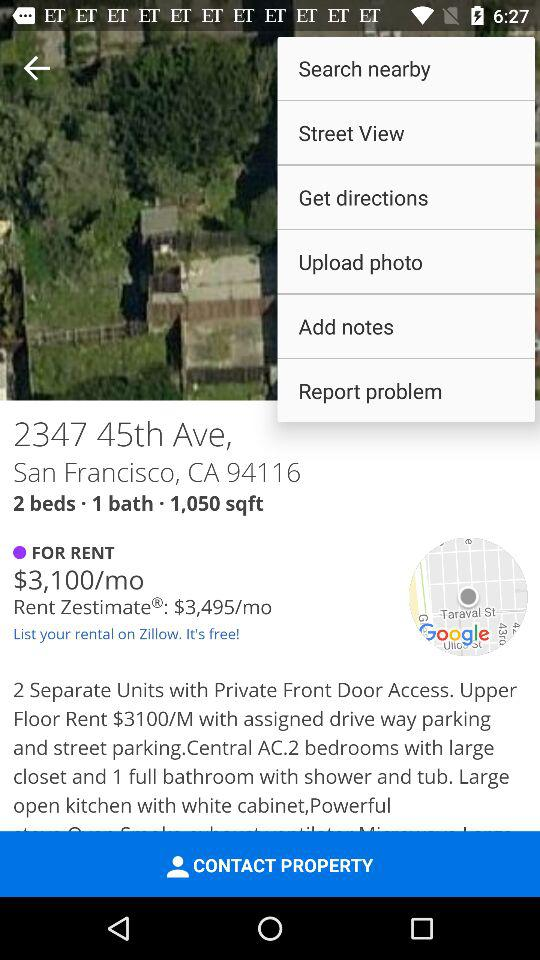How many rooms does the property have?
Answer the question using a single word or phrase. 2 